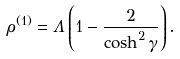Convert formula to latex. <formula><loc_0><loc_0><loc_500><loc_500>\rho ^ { ( 1 ) } = \Lambda \left ( 1 - \frac { 2 } { \cosh ^ { 2 } \gamma } \right ) .</formula> 